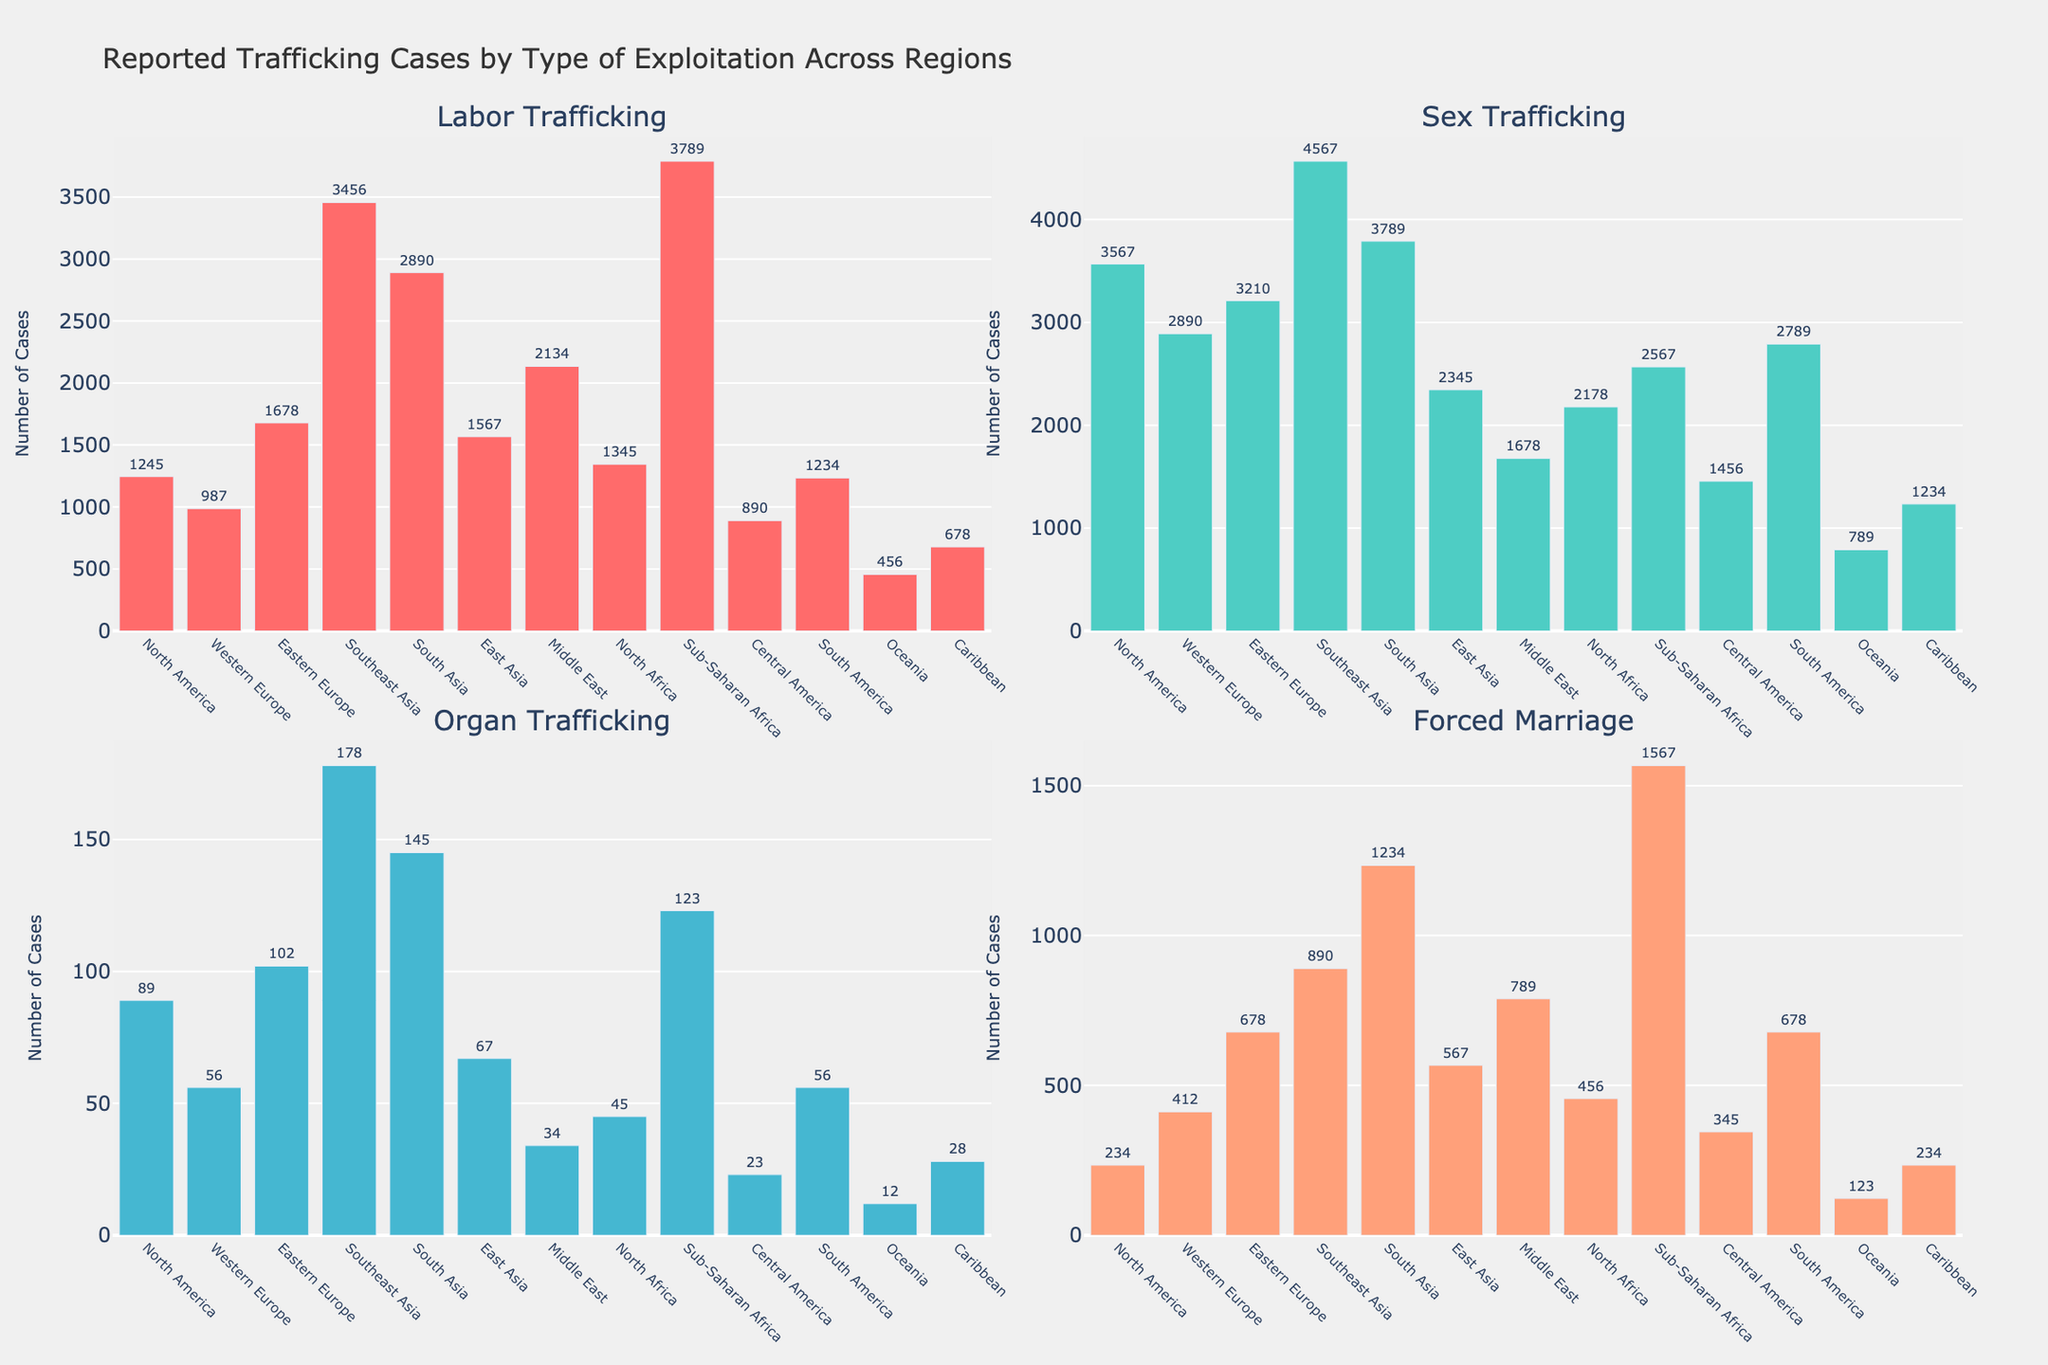Which region has the highest number of sex trafficking cases? By looking at the subplot for Sex Trafficking, Southeast Asia has the tallest bar. Therefore, the highest number of sex trafficking cases is in Southeast Asia.
Answer: Southeast Asia Which two regions have the closest number of forced marriage cases? By examining the Forced Marriage subplot, it appears that North America and the Caribbean have the closest number of cases.
Answer: North America, Caribbean What is the total number of labor trafficking cases reported in North America and Western Europe? By locating the bars corresponding to North America and Western Europe in the Labor Trafficking subplot, the number of cases are 1245 for North America and 987 for Western Europe. The total is 1245 + 987 = 2232.
Answer: 2232 Which region has fewer organ trafficking cases, Middle East or Oceania? On the Organ Trafficking subplot, the bar for the Middle East is higher than the bar for Oceania. This indicates fewer organ trafficking cases in Oceania.
Answer: Oceania By how many cases does South Asia exceed North Africa in forced marriage? By looking at the Forced Marriage subplot, South Asia has 1234 cases, and North Africa has 456 cases. The difference is 1234 - 456 = 778.
Answer: 778 Which region reports the second-highest number of labor trafficking cases? In the Labor Trafficking subplot, the tallest bar is for Sub-Saharan Africa, and the second tallest bar is for Southeast Asia. Therefore, Southeast Asia has the second-highest number of labor trafficking cases.
Answer: Southeast Asia What is the difference in the number of sex trafficking cases between Western Europe and Eastern Europe? Looking at the Sex Trafficking subplot, Western Europe has 2890 cases, and Eastern Europe has 3210 cases. The difference is 3210 - 2890 = 320.
Answer: 320 What is the combined total of organ trafficking cases for East Asia and the Caribbean? On the Organ Trafficking subplot, East Asia has 67 cases, and the Caribbean has 28 cases. The combined total is 67 + 28 = 95.
Answer: 95 How does the number of forced marriage cases in Southeast Asia compare to South America? In the Forced Marriage subplot, Southeast Asia has 890 cases, while South America has 678 cases. Therefore, Southeast Asia has more forced marriage cases than South America.
Answer: Southeast Asia Are there more sex trafficking cases in North America or forced marriage cases in Sub-Saharan Africa? Comparing the bars, North America has 3567 sex trafficking cases, and Sub-Saharan Africa has 1567 forced marriage cases. Therefore, North America has more sex trafficking cases.
Answer: North America 